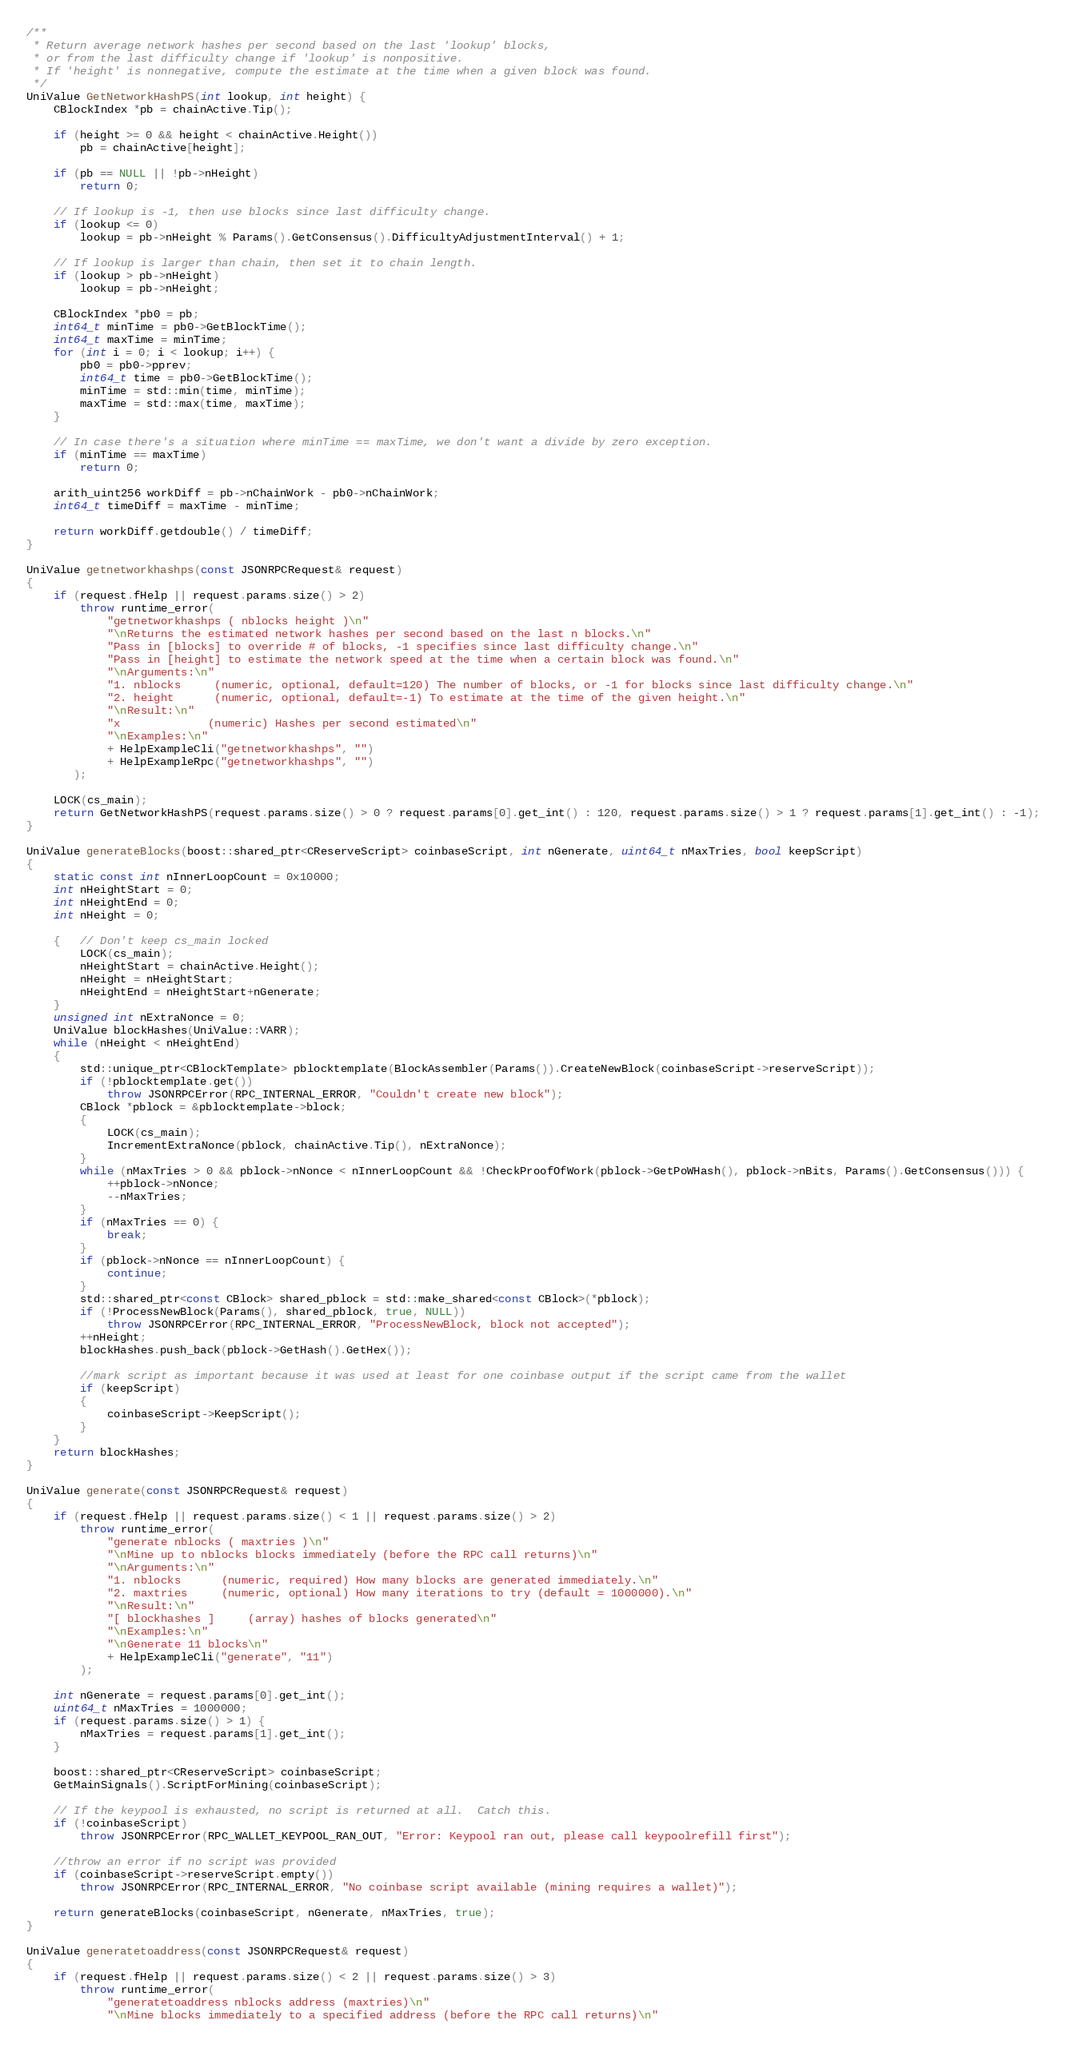Convert code to text. <code><loc_0><loc_0><loc_500><loc_500><_C++_>/**
 * Return average network hashes per second based on the last 'lookup' blocks,
 * or from the last difficulty change if 'lookup' is nonpositive.
 * If 'height' is nonnegative, compute the estimate at the time when a given block was found.
 */
UniValue GetNetworkHashPS(int lookup, int height) {
    CBlockIndex *pb = chainActive.Tip();

    if (height >= 0 && height < chainActive.Height())
        pb = chainActive[height];

    if (pb == NULL || !pb->nHeight)
        return 0;

    // If lookup is -1, then use blocks since last difficulty change.
    if (lookup <= 0)
        lookup = pb->nHeight % Params().GetConsensus().DifficultyAdjustmentInterval() + 1;

    // If lookup is larger than chain, then set it to chain length.
    if (lookup > pb->nHeight)
        lookup = pb->nHeight;

    CBlockIndex *pb0 = pb;
    int64_t minTime = pb0->GetBlockTime();
    int64_t maxTime = minTime;
    for (int i = 0; i < lookup; i++) {
        pb0 = pb0->pprev;
        int64_t time = pb0->GetBlockTime();
        minTime = std::min(time, minTime);
        maxTime = std::max(time, maxTime);
    }

    // In case there's a situation where minTime == maxTime, we don't want a divide by zero exception.
    if (minTime == maxTime)
        return 0;

    arith_uint256 workDiff = pb->nChainWork - pb0->nChainWork;
    int64_t timeDiff = maxTime - minTime;

    return workDiff.getdouble() / timeDiff;
}

UniValue getnetworkhashps(const JSONRPCRequest& request)
{
    if (request.fHelp || request.params.size() > 2)
        throw runtime_error(
            "getnetworkhashps ( nblocks height )\n"
            "\nReturns the estimated network hashes per second based on the last n blocks.\n"
            "Pass in [blocks] to override # of blocks, -1 specifies since last difficulty change.\n"
            "Pass in [height] to estimate the network speed at the time when a certain block was found.\n"
            "\nArguments:\n"
            "1. nblocks     (numeric, optional, default=120) The number of blocks, or -1 for blocks since last difficulty change.\n"
            "2. height      (numeric, optional, default=-1) To estimate at the time of the given height.\n"
            "\nResult:\n"
            "x             (numeric) Hashes per second estimated\n"
            "\nExamples:\n"
            + HelpExampleCli("getnetworkhashps", "")
            + HelpExampleRpc("getnetworkhashps", "")
       );

    LOCK(cs_main);
    return GetNetworkHashPS(request.params.size() > 0 ? request.params[0].get_int() : 120, request.params.size() > 1 ? request.params[1].get_int() : -1);
}

UniValue generateBlocks(boost::shared_ptr<CReserveScript> coinbaseScript, int nGenerate, uint64_t nMaxTries, bool keepScript)
{
    static const int nInnerLoopCount = 0x10000;
    int nHeightStart = 0;
    int nHeightEnd = 0;
    int nHeight = 0;

    {   // Don't keep cs_main locked
        LOCK(cs_main);
        nHeightStart = chainActive.Height();
        nHeight = nHeightStart;
        nHeightEnd = nHeightStart+nGenerate;
    }
    unsigned int nExtraNonce = 0;
    UniValue blockHashes(UniValue::VARR);
    while (nHeight < nHeightEnd)
    {
        std::unique_ptr<CBlockTemplate> pblocktemplate(BlockAssembler(Params()).CreateNewBlock(coinbaseScript->reserveScript));
        if (!pblocktemplate.get())
            throw JSONRPCError(RPC_INTERNAL_ERROR, "Couldn't create new block");
        CBlock *pblock = &pblocktemplate->block;
        {
            LOCK(cs_main);
            IncrementExtraNonce(pblock, chainActive.Tip(), nExtraNonce);
        }
        while (nMaxTries > 0 && pblock->nNonce < nInnerLoopCount && !CheckProofOfWork(pblock->GetPoWHash(), pblock->nBits, Params().GetConsensus())) {
            ++pblock->nNonce;
            --nMaxTries;
        }
        if (nMaxTries == 0) {
            break;
        }
        if (pblock->nNonce == nInnerLoopCount) {
            continue;
        }
        std::shared_ptr<const CBlock> shared_pblock = std::make_shared<const CBlock>(*pblock);
        if (!ProcessNewBlock(Params(), shared_pblock, true, NULL))
            throw JSONRPCError(RPC_INTERNAL_ERROR, "ProcessNewBlock, block not accepted");
        ++nHeight;
        blockHashes.push_back(pblock->GetHash().GetHex());

        //mark script as important because it was used at least for one coinbase output if the script came from the wallet
        if (keepScript)
        {
            coinbaseScript->KeepScript();
        }
    }
    return blockHashes;
}

UniValue generate(const JSONRPCRequest& request)
{
    if (request.fHelp || request.params.size() < 1 || request.params.size() > 2)
        throw runtime_error(
            "generate nblocks ( maxtries )\n"
            "\nMine up to nblocks blocks immediately (before the RPC call returns)\n"
            "\nArguments:\n"
            "1. nblocks      (numeric, required) How many blocks are generated immediately.\n"
            "2. maxtries     (numeric, optional) How many iterations to try (default = 1000000).\n"
            "\nResult:\n"
            "[ blockhashes ]     (array) hashes of blocks generated\n"
            "\nExamples:\n"
            "\nGenerate 11 blocks\n"
            + HelpExampleCli("generate", "11")
        );

    int nGenerate = request.params[0].get_int();
    uint64_t nMaxTries = 1000000;
    if (request.params.size() > 1) {
        nMaxTries = request.params[1].get_int();
    }

    boost::shared_ptr<CReserveScript> coinbaseScript;
    GetMainSignals().ScriptForMining(coinbaseScript);

    // If the keypool is exhausted, no script is returned at all.  Catch this.
    if (!coinbaseScript)
        throw JSONRPCError(RPC_WALLET_KEYPOOL_RAN_OUT, "Error: Keypool ran out, please call keypoolrefill first");

    //throw an error if no script was provided
    if (coinbaseScript->reserveScript.empty())
        throw JSONRPCError(RPC_INTERNAL_ERROR, "No coinbase script available (mining requires a wallet)");

    return generateBlocks(coinbaseScript, nGenerate, nMaxTries, true);
}

UniValue generatetoaddress(const JSONRPCRequest& request)
{
    if (request.fHelp || request.params.size() < 2 || request.params.size() > 3)
        throw runtime_error(
            "generatetoaddress nblocks address (maxtries)\n"
            "\nMine blocks immediately to a specified address (before the RPC call returns)\n"</code> 